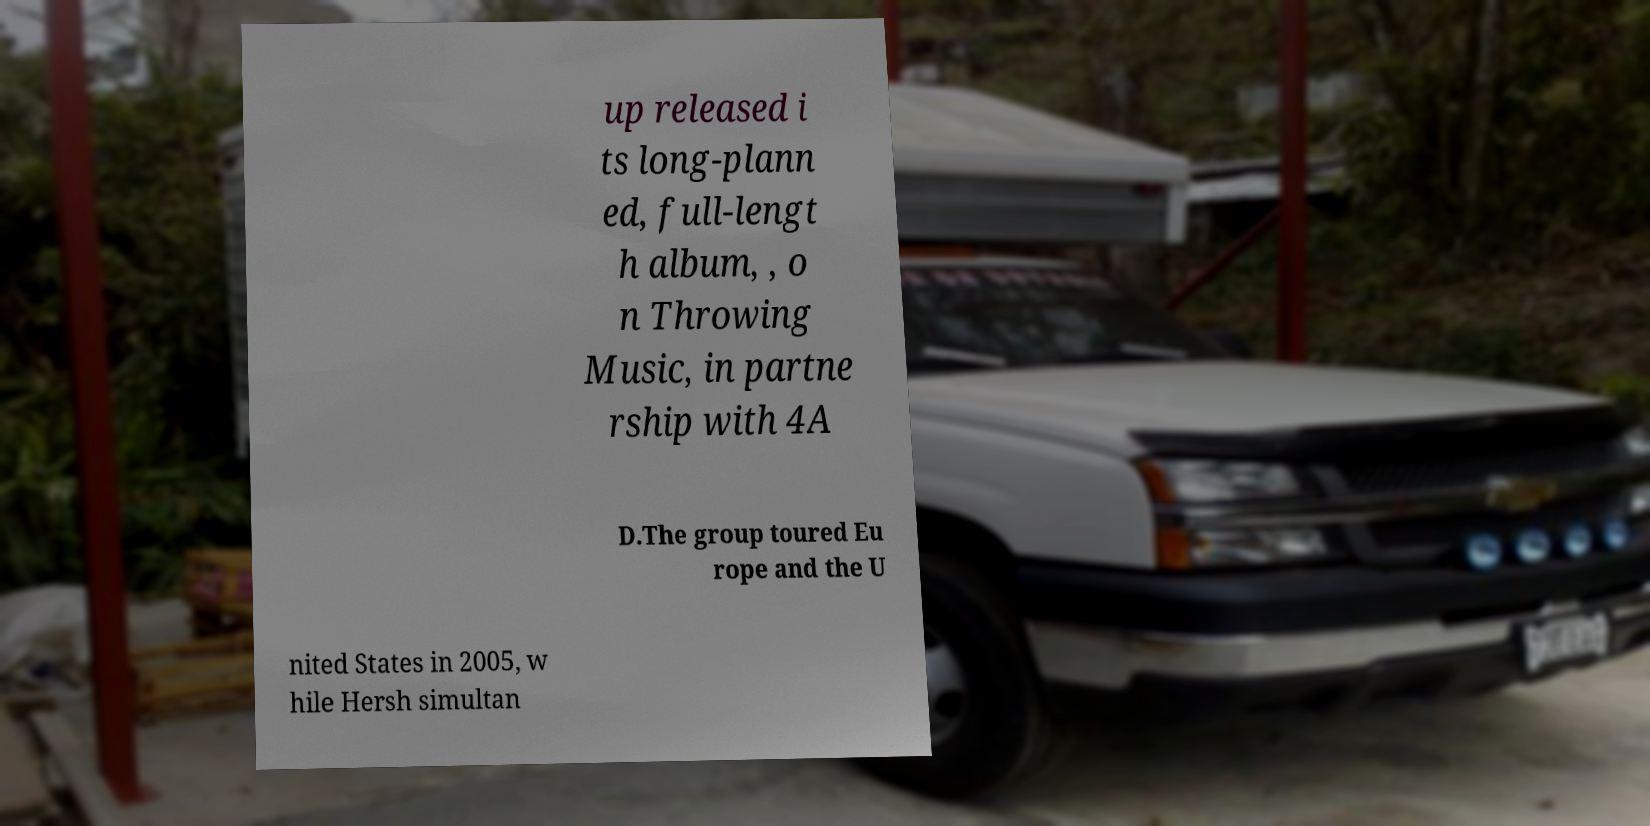Can you accurately transcribe the text from the provided image for me? up released i ts long-plann ed, full-lengt h album, , o n Throwing Music, in partne rship with 4A D.The group toured Eu rope and the U nited States in 2005, w hile Hersh simultan 